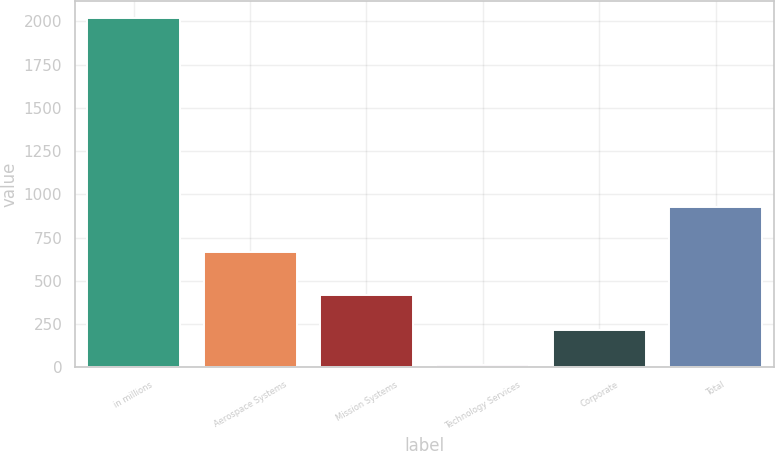Convert chart to OTSL. <chart><loc_0><loc_0><loc_500><loc_500><bar_chart><fcel>in millions<fcel>Aerospace Systems<fcel>Mission Systems<fcel>Technology Services<fcel>Corporate<fcel>Total<nl><fcel>2017<fcel>665<fcel>415.4<fcel>15<fcel>215.2<fcel>928<nl></chart> 